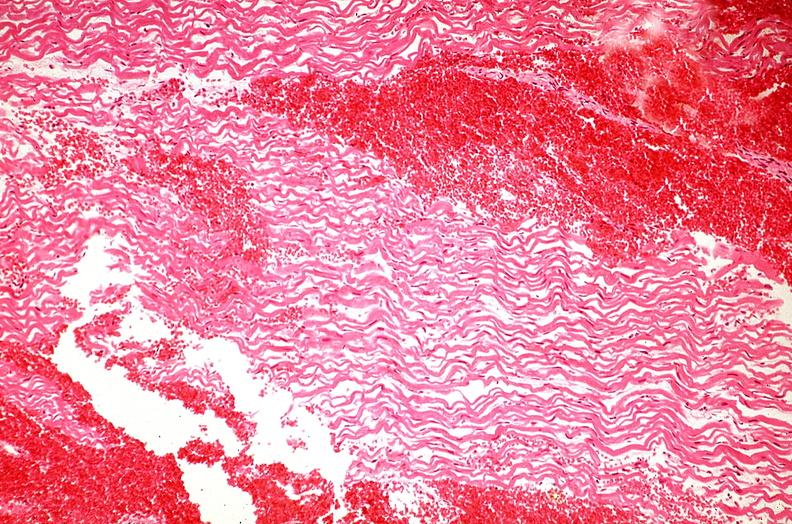does this image show heart, myocardial infarction, wavey fiber change, necrtosis, hemorrhage, and dissection?
Answer the question using a single word or phrase. Yes 